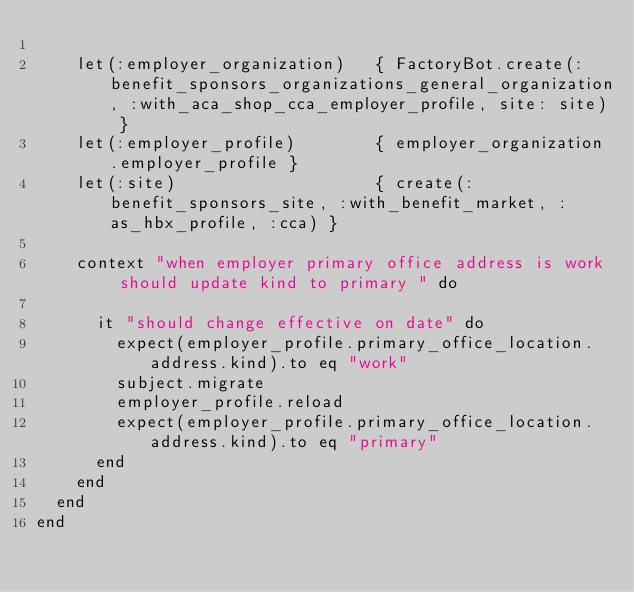Convert code to text. <code><loc_0><loc_0><loc_500><loc_500><_Ruby_>
    let(:employer_organization)   { FactoryBot.create(:benefit_sponsors_organizations_general_organization, :with_aca_shop_cca_employer_profile, site: site) }
    let(:employer_profile)        { employer_organization.employer_profile }
    let(:site)                    { create(:benefit_sponsors_site, :with_benefit_market, :as_hbx_profile, :cca) }

    context "when employer primary office address is work should update kind to primary " do

      it "should change effective on date" do
        expect(employer_profile.primary_office_location.address.kind).to eq "work"
        subject.migrate
        employer_profile.reload
        expect(employer_profile.primary_office_location.address.kind).to eq "primary"
      end
    end
  end
end
</code> 